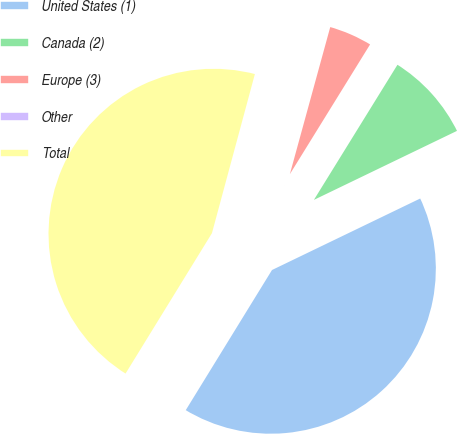Convert chart to OTSL. <chart><loc_0><loc_0><loc_500><loc_500><pie_chart><fcel>United States (1)<fcel>Canada (2)<fcel>Europe (3)<fcel>Other<fcel>Total<nl><fcel>40.93%<fcel>9.03%<fcel>4.55%<fcel>0.07%<fcel>45.41%<nl></chart> 